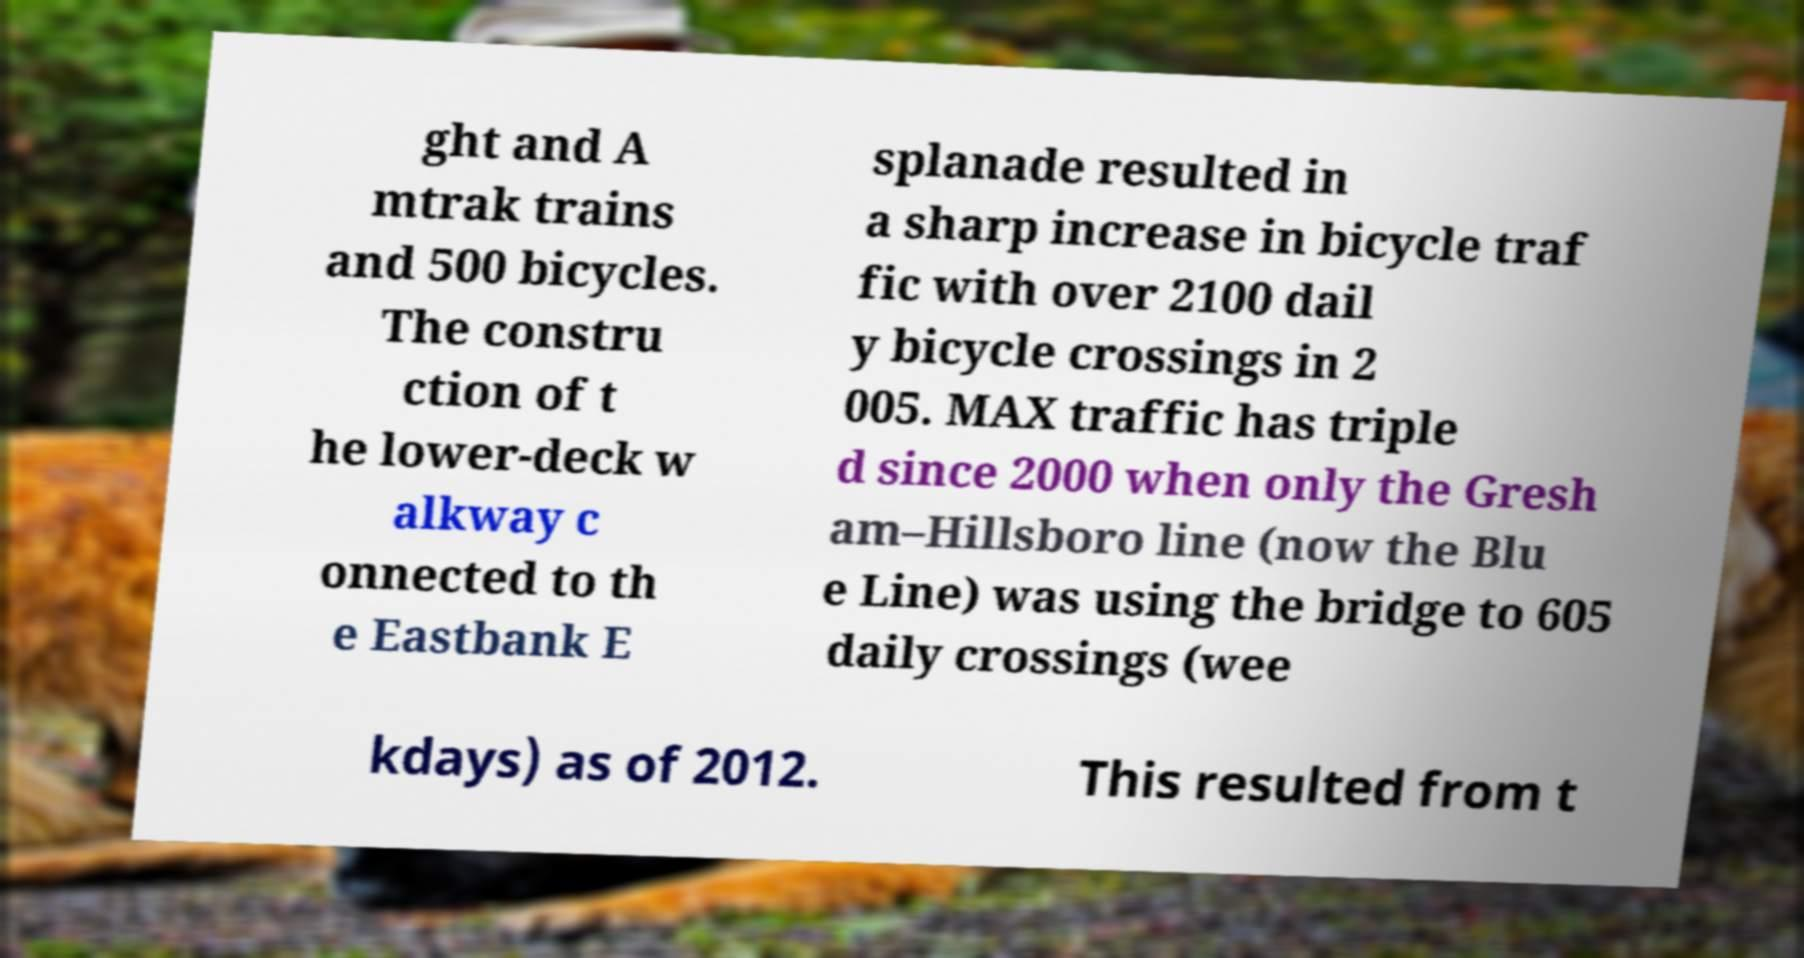Could you extract and type out the text from this image? ght and A mtrak trains and 500 bicycles. The constru ction of t he lower-deck w alkway c onnected to th e Eastbank E splanade resulted in a sharp increase in bicycle traf fic with over 2100 dail y bicycle crossings in 2 005. MAX traffic has triple d since 2000 when only the Gresh am–Hillsboro line (now the Blu e Line) was using the bridge to 605 daily crossings (wee kdays) as of 2012. This resulted from t 